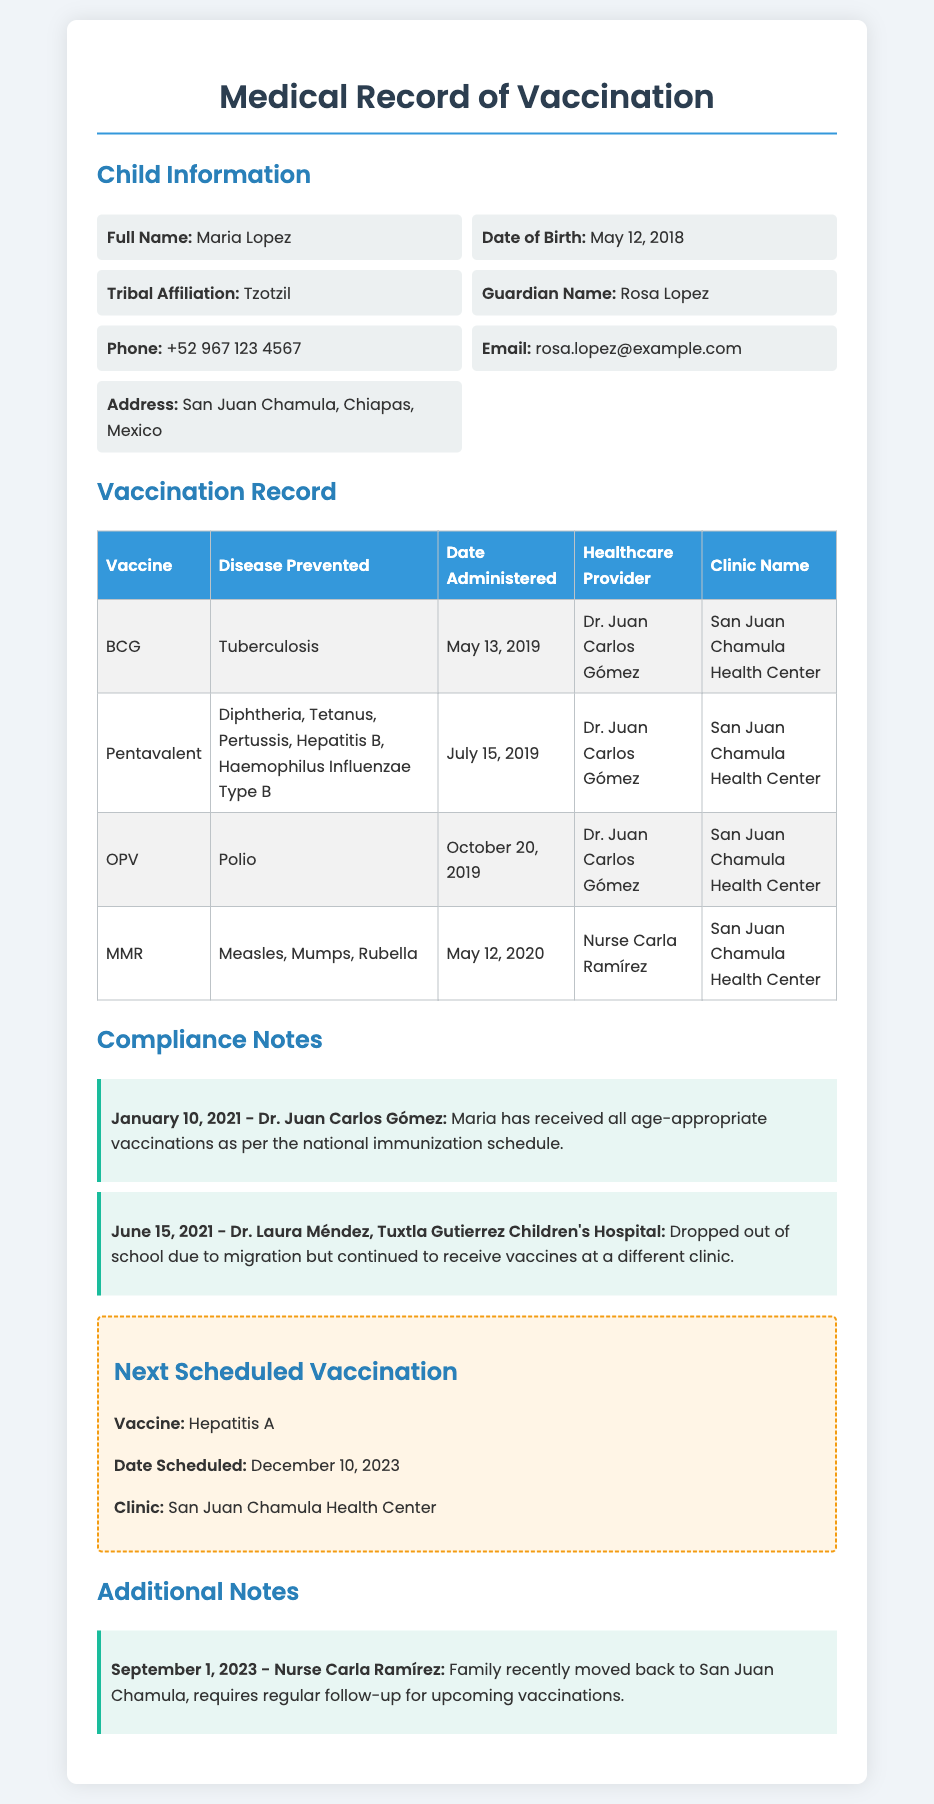What is the child's full name? The child's full name is listed in the document under "Full Name."
Answer: Maria Lopez What is the date of birth? The date of birth is specified in the child information section.
Answer: May 12, 2018 What vaccine was administered on October 20, 2019? The document contains a table listing vaccines and their administration dates.
Answer: OPV Who was the healthcare provider for the MMR vaccine? The healthcare provider for each vaccine is noted in the vaccination record table.
Answer: Nurse Carla Ramírez What is the next scheduled vaccination date? The document specifies the date for the next vaccination under "Next Scheduled Vaccination."
Answer: December 10, 2023 What clinic is Maria scheduled to visit for the next vaccination? The clinic name for the upcoming vaccination is mentioned in the "Next Scheduled Vaccination" section.
Answer: San Juan Chamula Health Center How many compliance notes are recorded? The number of compliance notes can be counted from the "Compliance Notes" section of the document.
Answer: 2 What is Maria’s tribal affiliation? The tribal affiliation is found in the child information section of the document.
Answer: Tzotzil What additional follow-up is required as per the notes? The additional notes section mentions the requirement for regular follow-up for vaccinations.
Answer: Regular follow-up for upcoming vaccinations 